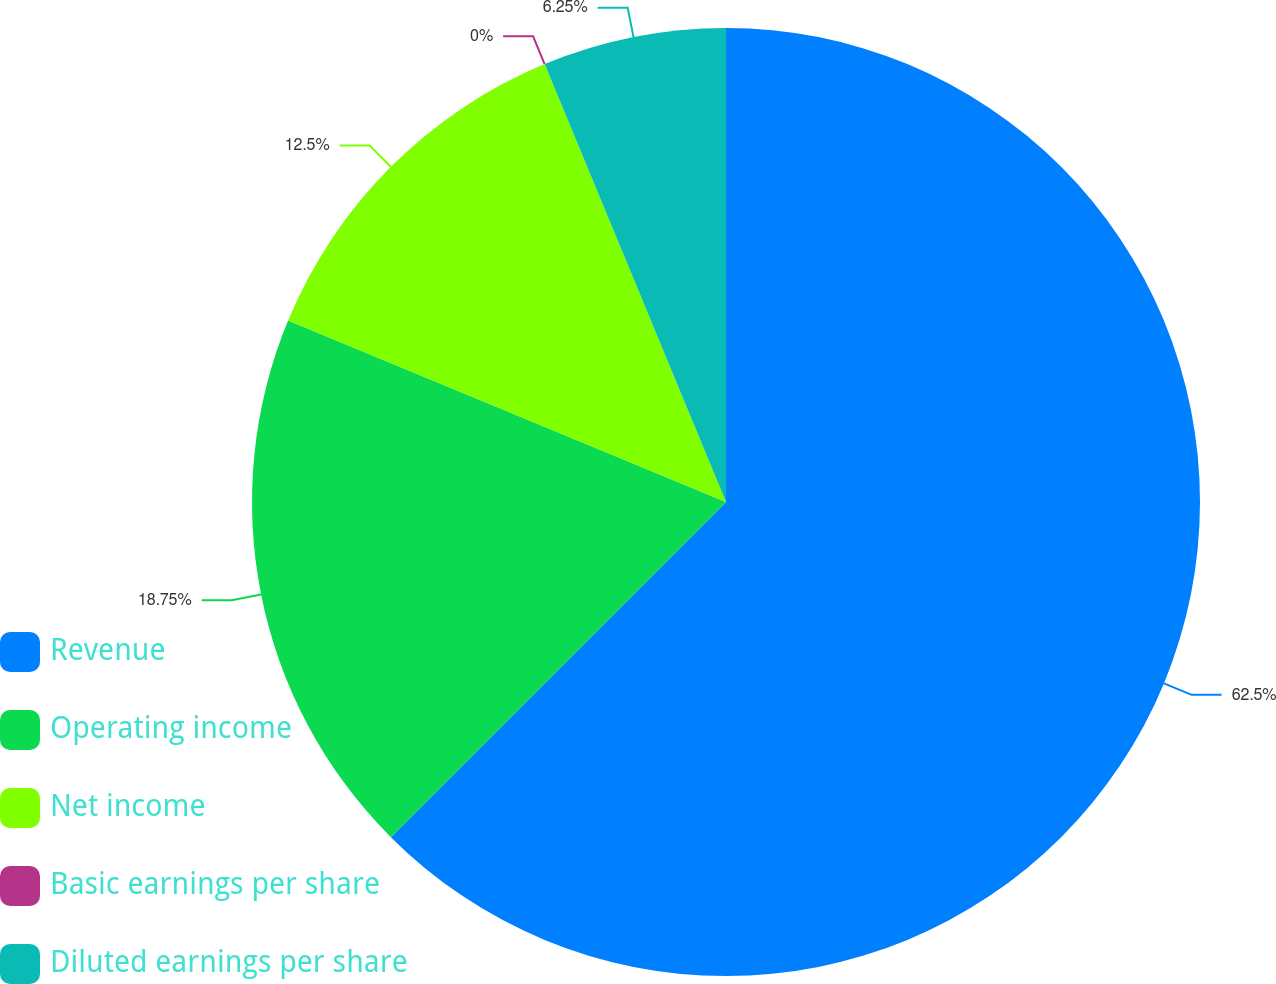Convert chart. <chart><loc_0><loc_0><loc_500><loc_500><pie_chart><fcel>Revenue<fcel>Operating income<fcel>Net income<fcel>Basic earnings per share<fcel>Diluted earnings per share<nl><fcel>62.5%<fcel>18.75%<fcel>12.5%<fcel>0.0%<fcel>6.25%<nl></chart> 